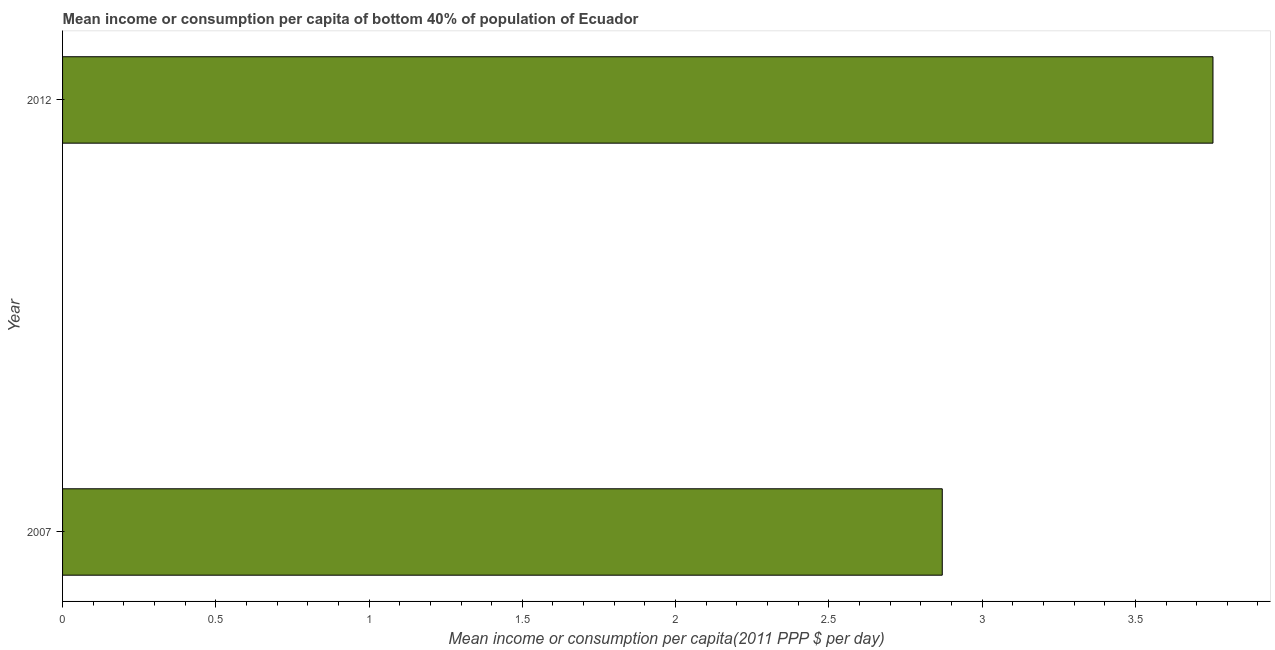Does the graph contain any zero values?
Make the answer very short. No. Does the graph contain grids?
Offer a terse response. No. What is the title of the graph?
Offer a very short reply. Mean income or consumption per capita of bottom 40% of population of Ecuador. What is the label or title of the X-axis?
Give a very brief answer. Mean income or consumption per capita(2011 PPP $ per day). What is the label or title of the Y-axis?
Provide a short and direct response. Year. What is the mean income or consumption in 2007?
Your answer should be compact. 2.87. Across all years, what is the maximum mean income or consumption?
Your answer should be very brief. 3.75. Across all years, what is the minimum mean income or consumption?
Ensure brevity in your answer.  2.87. In which year was the mean income or consumption maximum?
Offer a very short reply. 2012. What is the sum of the mean income or consumption?
Your response must be concise. 6.62. What is the difference between the mean income or consumption in 2007 and 2012?
Provide a succinct answer. -0.88. What is the average mean income or consumption per year?
Keep it short and to the point. 3.31. What is the median mean income or consumption?
Keep it short and to the point. 3.31. Do a majority of the years between 2007 and 2012 (inclusive) have mean income or consumption greater than 3.2 $?
Your answer should be very brief. No. What is the ratio of the mean income or consumption in 2007 to that in 2012?
Your answer should be compact. 0.77. How many bars are there?
Your answer should be compact. 2. How many years are there in the graph?
Make the answer very short. 2. What is the difference between two consecutive major ticks on the X-axis?
Your answer should be compact. 0.5. What is the Mean income or consumption per capita(2011 PPP $ per day) in 2007?
Your answer should be very brief. 2.87. What is the Mean income or consumption per capita(2011 PPP $ per day) of 2012?
Your answer should be very brief. 3.75. What is the difference between the Mean income or consumption per capita(2011 PPP $ per day) in 2007 and 2012?
Give a very brief answer. -0.88. What is the ratio of the Mean income or consumption per capita(2011 PPP $ per day) in 2007 to that in 2012?
Your answer should be very brief. 0.77. 